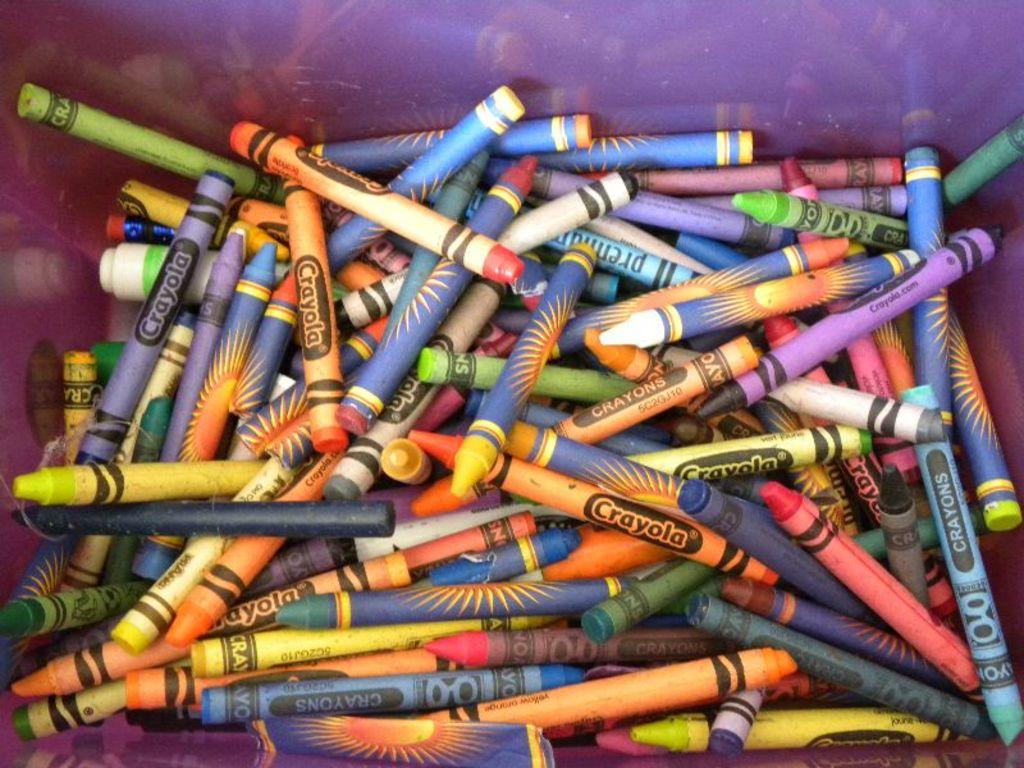Provide a one-sentence caption for the provided image. Several crayola crayons are mixed in a bin with non-crayola crayons. 